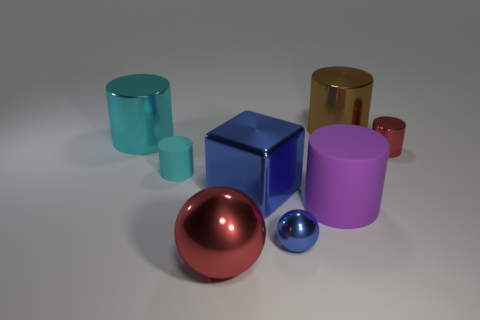What color is the big cube that is the same material as the tiny red object?
Give a very brief answer. Blue. What number of purple things have the same material as the red sphere?
Your answer should be compact. 0. Does the purple object have the same material as the big object that is behind the big cyan thing?
Ensure brevity in your answer.  No. How many things are cyan cylinders in front of the small red thing or red metal things?
Your answer should be very brief. 3. How big is the thing that is in front of the sphere that is to the right of the red object in front of the large blue object?
Offer a terse response. Large. There is a large thing that is the same color as the tiny shiny cylinder; what is it made of?
Your answer should be compact. Metal. Are there any other things that are the same shape as the big matte object?
Offer a very short reply. Yes. How big is the red shiny thing to the left of the large metallic cylinder on the right side of the large sphere?
Your answer should be very brief. Large. What number of large objects are matte things or purple rubber things?
Provide a short and direct response. 1. Are there fewer brown metallic blocks than purple rubber cylinders?
Offer a very short reply. Yes. 